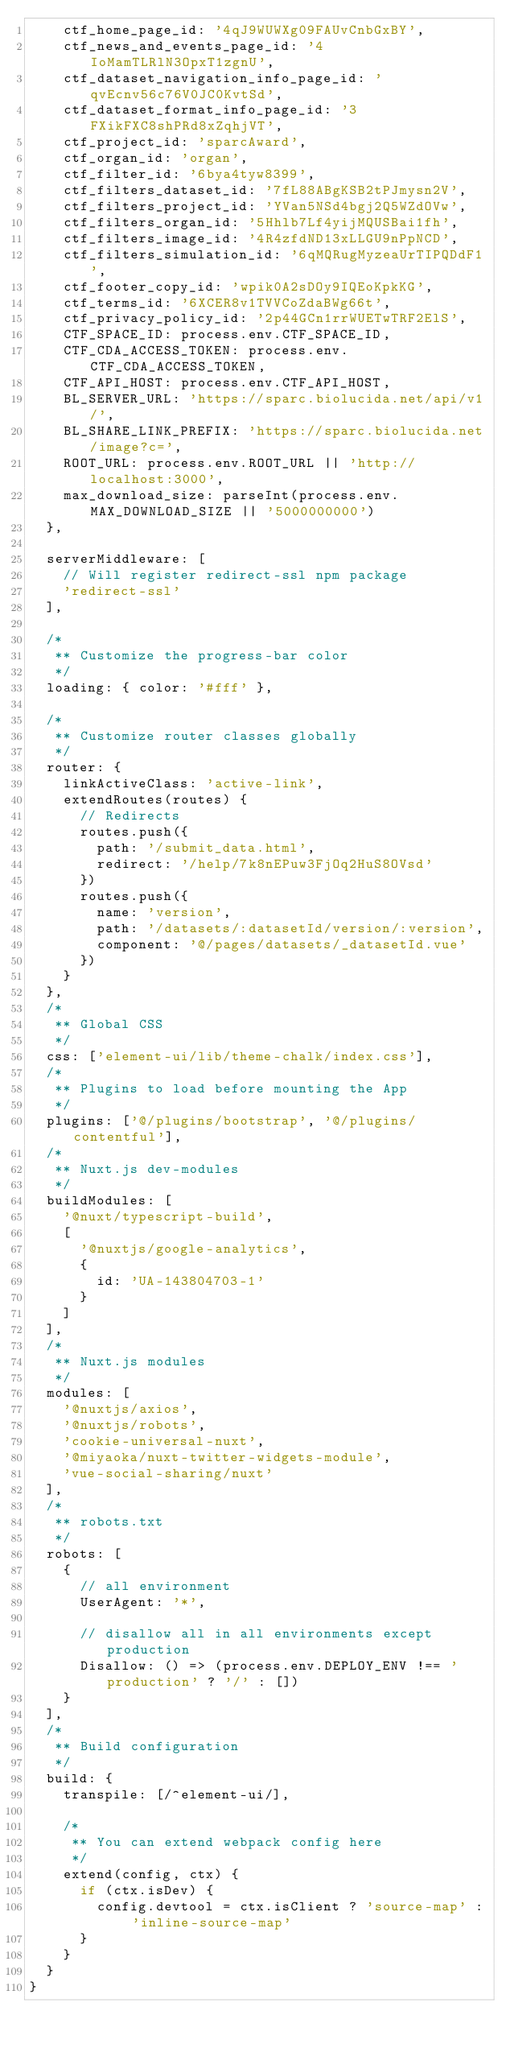<code> <loc_0><loc_0><loc_500><loc_500><_JavaScript_>    ctf_home_page_id: '4qJ9WUWXg09FAUvCnbGxBY',
    ctf_news_and_events_page_id: '4IoMamTLRlN3OpxT1zgnU',
    ctf_dataset_navigation_info_page_id: 'qvEcnv56c76V0JC0KvtSd',
    ctf_dataset_format_info_page_id: '3FXikFXC8shPRd8xZqhjVT',
    ctf_project_id: 'sparcAward',
    ctf_organ_id: 'organ',
    ctf_filter_id: '6bya4tyw8399',
    ctf_filters_dataset_id: '7fL88ABgKSB2tPJmysn2V',
    ctf_filters_project_id: 'YVan5NSd4bgj2Q5WZdOVw',
    ctf_filters_organ_id: '5Hhlb7Lf4yijMQUSBai1fh',
    ctf_filters_image_id: '4R4zfdND13xLLGU9nPpNCD',
    ctf_filters_simulation_id: '6qMQRugMyzeaUrTIPQDdF1',
    ctf_footer_copy_id: 'wpik0A2sDOy9IQEoKpkKG',
    ctf_terms_id: '6XCER8v1TVVCoZdaBWg66t',
    ctf_privacy_policy_id: '2p44GCn1rrWUETwTRF2ElS',
    CTF_SPACE_ID: process.env.CTF_SPACE_ID,
    CTF_CDA_ACCESS_TOKEN: process.env.CTF_CDA_ACCESS_TOKEN,
    CTF_API_HOST: process.env.CTF_API_HOST,
    BL_SERVER_URL: 'https://sparc.biolucida.net/api/v1/',
    BL_SHARE_LINK_PREFIX: 'https://sparc.biolucida.net/image?c=',
    ROOT_URL: process.env.ROOT_URL || 'http://localhost:3000',
    max_download_size: parseInt(process.env.MAX_DOWNLOAD_SIZE || '5000000000')
  },

  serverMiddleware: [
    // Will register redirect-ssl npm package
    'redirect-ssl'
  ],

  /*
   ** Customize the progress-bar color
   */
  loading: { color: '#fff' },

  /*
   ** Customize router classes globally
   */
  router: {
    linkActiveClass: 'active-link',
    extendRoutes(routes) {
      // Redirects
      routes.push({
        path: '/submit_data.html',
        redirect: '/help/7k8nEPuw3FjOq2HuS8OVsd'
      })
      routes.push({
        name: 'version',
        path: '/datasets/:datasetId/version/:version',
        component: '@/pages/datasets/_datasetId.vue'
      })
    }
  },
  /*
   ** Global CSS
   */
  css: ['element-ui/lib/theme-chalk/index.css'],
  /*
   ** Plugins to load before mounting the App
   */
  plugins: ['@/plugins/bootstrap', '@/plugins/contentful'],
  /*
   ** Nuxt.js dev-modules
   */
  buildModules: [
    '@nuxt/typescript-build',
    [
      '@nuxtjs/google-analytics',
      {
        id: 'UA-143804703-1'
      }
    ]
  ],
  /*
   ** Nuxt.js modules
   */
  modules: [
    '@nuxtjs/axios',
    '@nuxtjs/robots',
    'cookie-universal-nuxt',
    '@miyaoka/nuxt-twitter-widgets-module',
    'vue-social-sharing/nuxt'
  ],
  /*
   ** robots.txt
   */
  robots: [
    {
      // all environment
      UserAgent: '*',

      // disallow all in all environments except production
      Disallow: () => (process.env.DEPLOY_ENV !== 'production' ? '/' : [])
    }
  ],
  /*
   ** Build configuration
   */
  build: {
    transpile: [/^element-ui/],

    /*
     ** You can extend webpack config here
     */
    extend(config, ctx) {
      if (ctx.isDev) {
        config.devtool = ctx.isClient ? 'source-map' : 'inline-source-map'
      }
    }
  }
}
</code> 